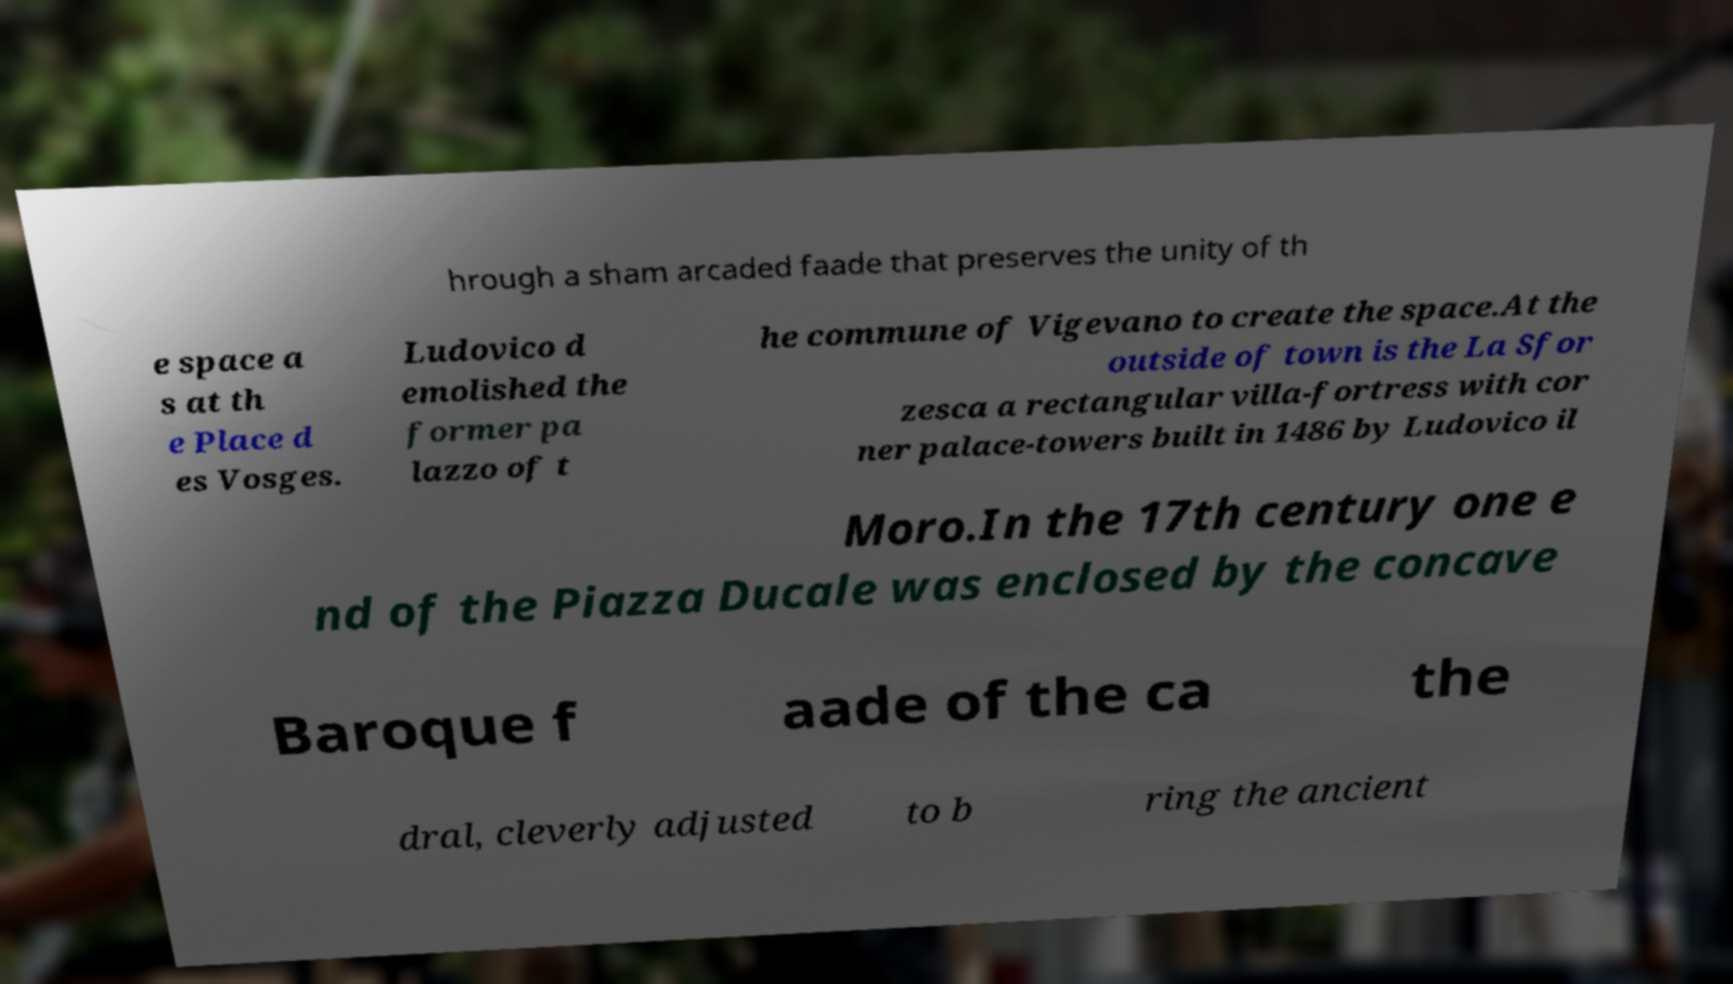Please identify and transcribe the text found in this image. hrough a sham arcaded faade that preserves the unity of th e space a s at th e Place d es Vosges. Ludovico d emolished the former pa lazzo of t he commune of Vigevano to create the space.At the outside of town is the La Sfor zesca a rectangular villa-fortress with cor ner palace-towers built in 1486 by Ludovico il Moro.In the 17th century one e nd of the Piazza Ducale was enclosed by the concave Baroque f aade of the ca the dral, cleverly adjusted to b ring the ancient 